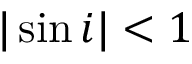Convert formula to latex. <formula><loc_0><loc_0><loc_500><loc_500>| \sin i | < 1</formula> 